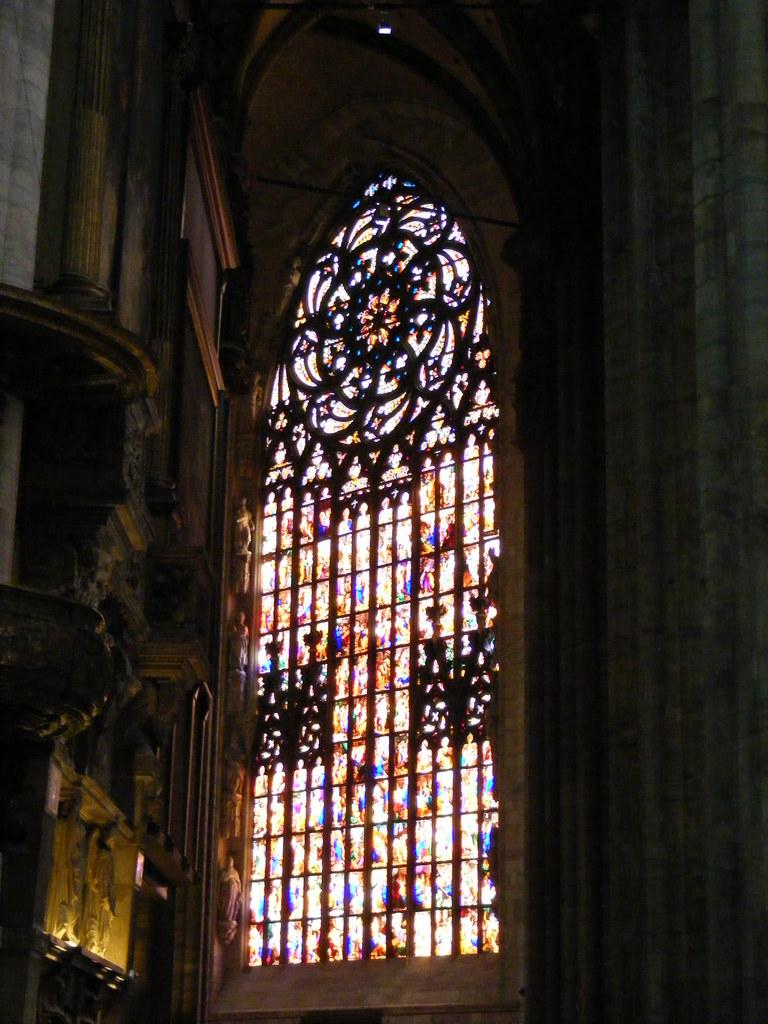What type of structure is present in the image? There is a building in the image. Can you describe any specific features of the building? The building has a glass window. What type of rhythm is being taught in the class inside the building? There is no class or indication of any rhythm-related activity inside the building in the image. 